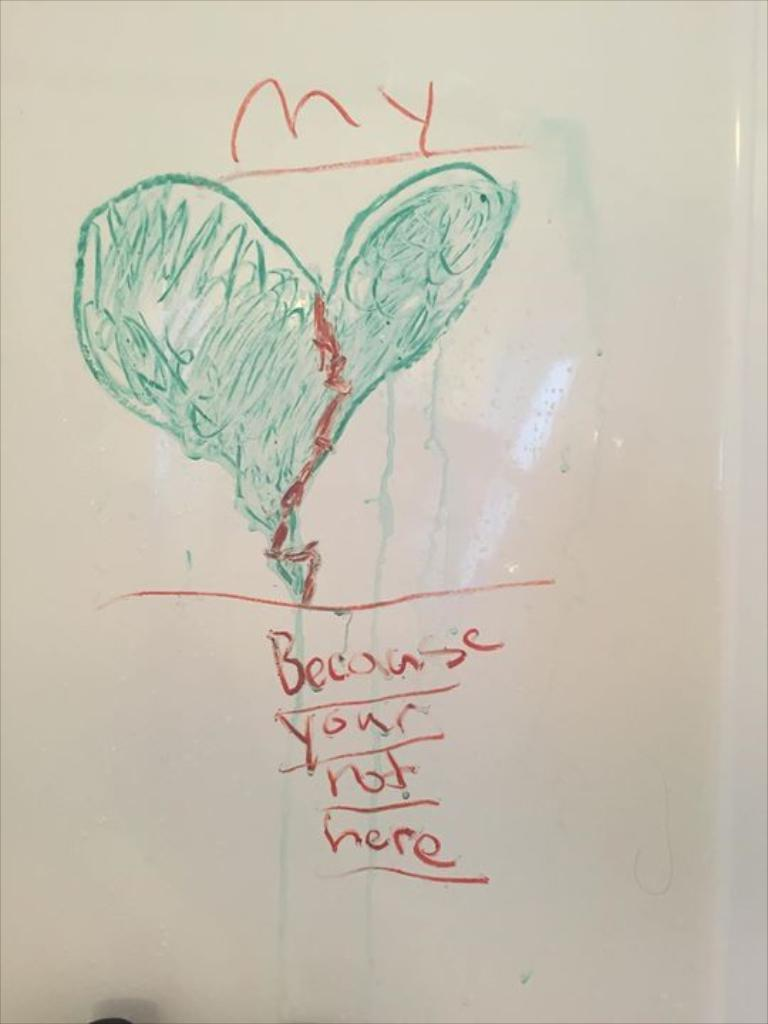<image>
Write a terse but informative summary of the picture. A white board contains a note that says "because your not here." 